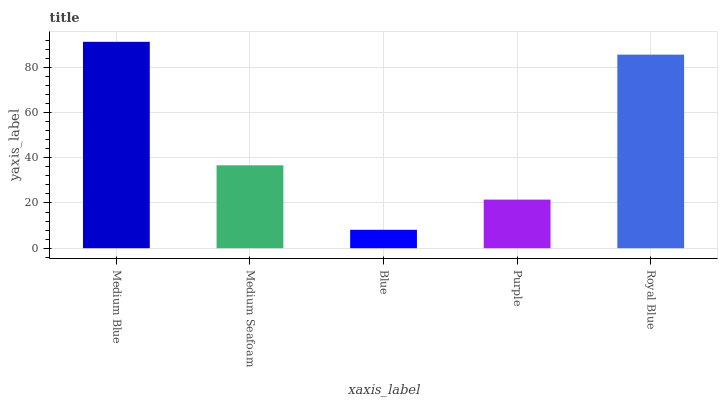Is Blue the minimum?
Answer yes or no. Yes. Is Medium Blue the maximum?
Answer yes or no. Yes. Is Medium Seafoam the minimum?
Answer yes or no. No. Is Medium Seafoam the maximum?
Answer yes or no. No. Is Medium Blue greater than Medium Seafoam?
Answer yes or no. Yes. Is Medium Seafoam less than Medium Blue?
Answer yes or no. Yes. Is Medium Seafoam greater than Medium Blue?
Answer yes or no. No. Is Medium Blue less than Medium Seafoam?
Answer yes or no. No. Is Medium Seafoam the high median?
Answer yes or no. Yes. Is Medium Seafoam the low median?
Answer yes or no. Yes. Is Purple the high median?
Answer yes or no. No. Is Medium Blue the low median?
Answer yes or no. No. 